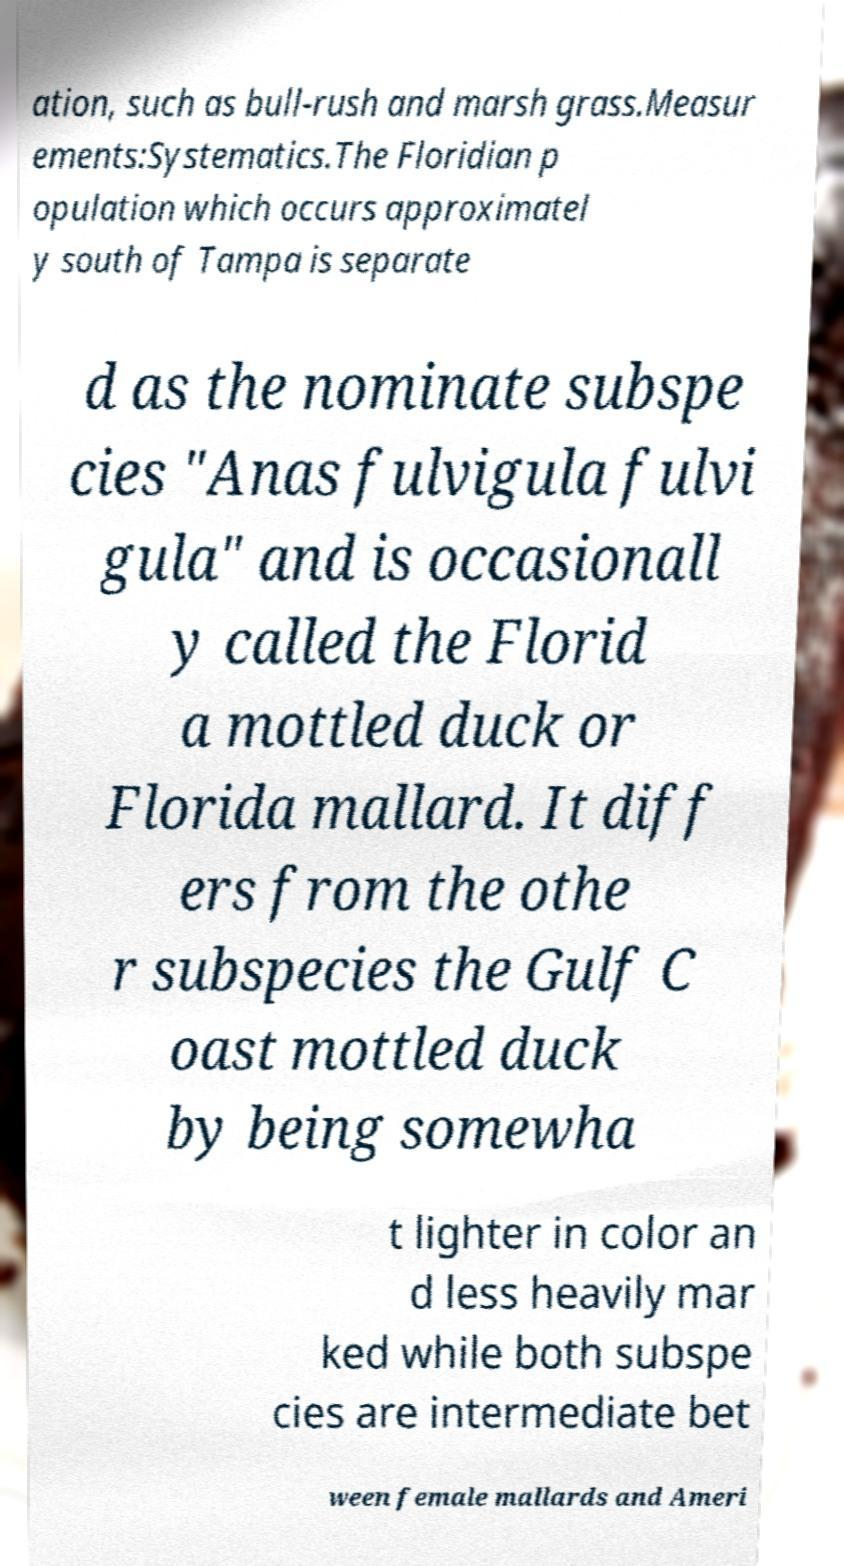For documentation purposes, I need the text within this image transcribed. Could you provide that? ation, such as bull-rush and marsh grass.Measur ements:Systematics.The Floridian p opulation which occurs approximatel y south of Tampa is separate d as the nominate subspe cies "Anas fulvigula fulvi gula" and is occasionall y called the Florid a mottled duck or Florida mallard. It diff ers from the othe r subspecies the Gulf C oast mottled duck by being somewha t lighter in color an d less heavily mar ked while both subspe cies are intermediate bet ween female mallards and Ameri 